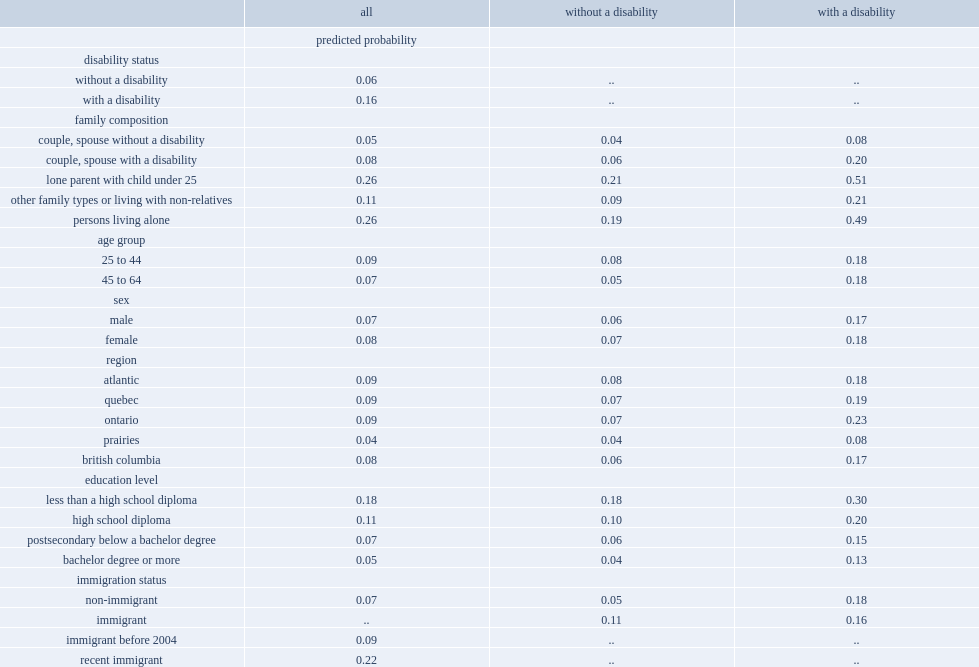According to the regression for the full population, after controlling for other factors, what was the probability of being in low income for persons with a disability? 0.16. According to the regression for the full population, after controlling for other factors, what was the probability of being in low income for persons without a disability? 0.06. Among people without a disability, which type of people were less likely to be in low income, those with a postsecondary education below the bachelor level or those with a high school diploma? Postsecondary below a bachelor degree. What was the probability of lone parents with a disability to be in low income? 0.51. What was the probability of people living alone with a disability to be in low income? 0.49. What was the probability of people with a disability living with a spouse who did not have a disability to be in low income? 0.08. 